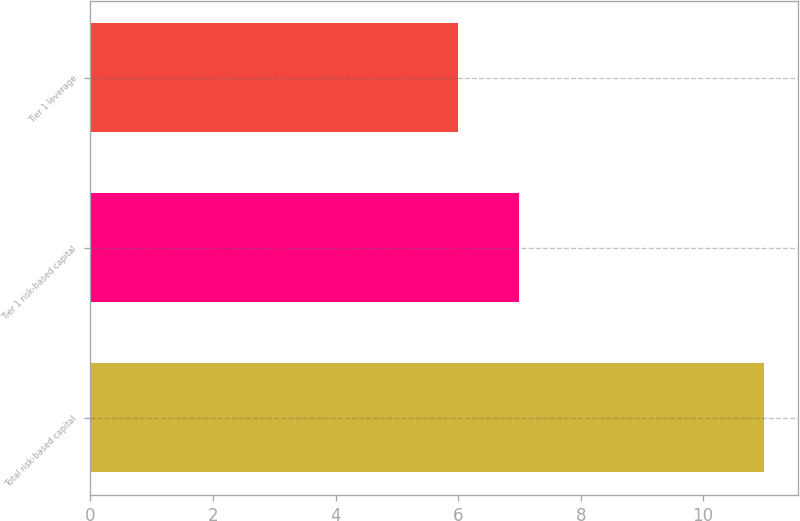Convert chart. <chart><loc_0><loc_0><loc_500><loc_500><bar_chart><fcel>Total risk-based capital<fcel>Tier 1 risk-based capital<fcel>Tier 1 leverage<nl><fcel>11<fcel>7<fcel>6<nl></chart> 